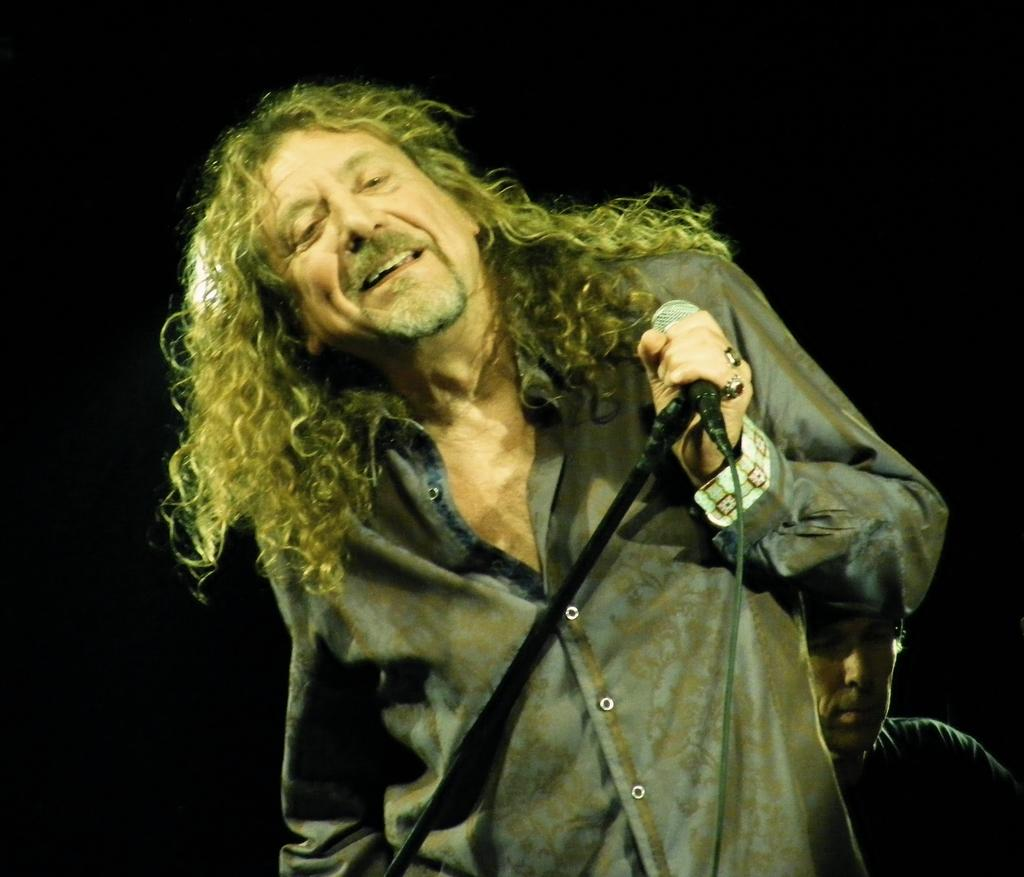Who is the main subject in the image? There is a person in the center of the image. What is the person holding in the image? The person is holding a microphone. What activity is the person engaged in? The person appears to be singing. Can you describe the background of the image? There is another person and a wall in the background of the image. What type of building can be seen in the background of the image? There is no building visible in the background of the image; it only shows a wall. What force is being exerted by the person singing in the image? There is no information about any force being exerted by the person singing in the image. 